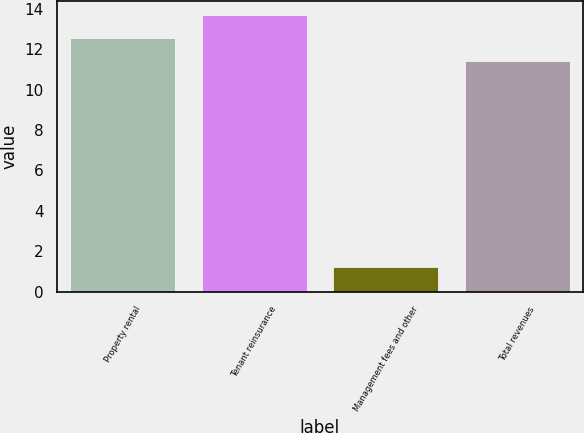Convert chart to OTSL. <chart><loc_0><loc_0><loc_500><loc_500><bar_chart><fcel>Property rental<fcel>Tenant reinsurance<fcel>Management fees and other<fcel>Total revenues<nl><fcel>12.55<fcel>13.7<fcel>1.2<fcel>11.4<nl></chart> 